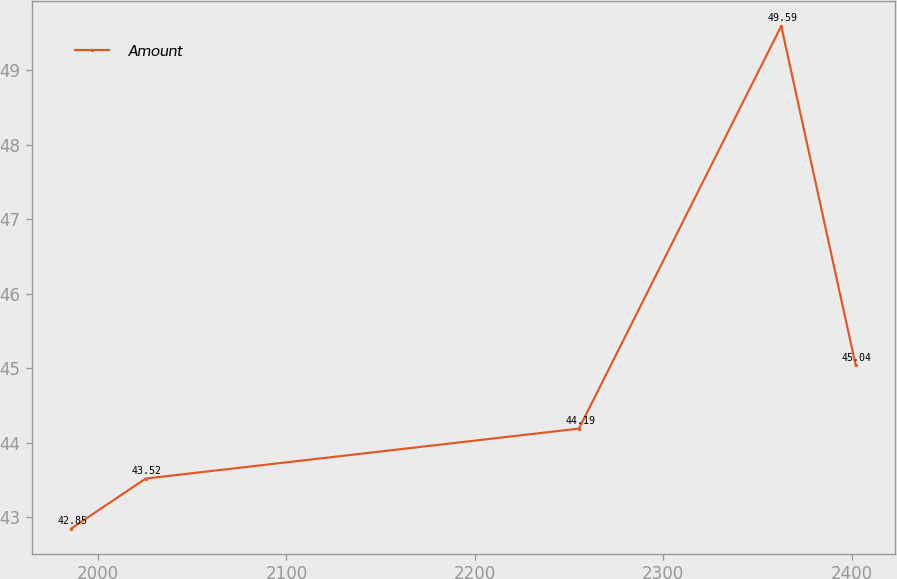Convert chart to OTSL. <chart><loc_0><loc_0><loc_500><loc_500><line_chart><ecel><fcel>Amount<nl><fcel>1985.81<fcel>42.85<nl><fcel>2025.31<fcel>43.52<nl><fcel>2255.19<fcel>44.19<nl><fcel>2362.54<fcel>49.59<nl><fcel>2402.04<fcel>45.04<nl></chart> 